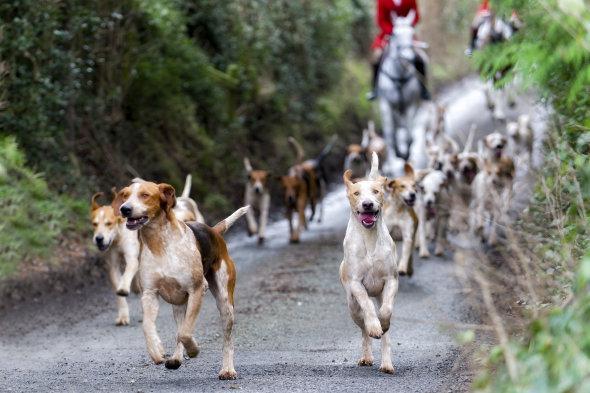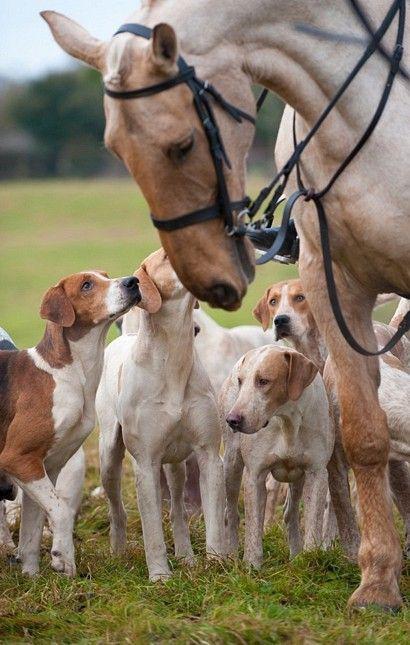The first image is the image on the left, the second image is the image on the right. Assess this claim about the two images: "People in coats are riding horses with several dogs in the image on the left.". Correct or not? Answer yes or no. Yes. The first image is the image on the left, the second image is the image on the right. Assess this claim about the two images: "Each image includes at least one horse and multiple beagles, and at least one image includes a rider wearing red.". Correct or not? Answer yes or no. Yes. 